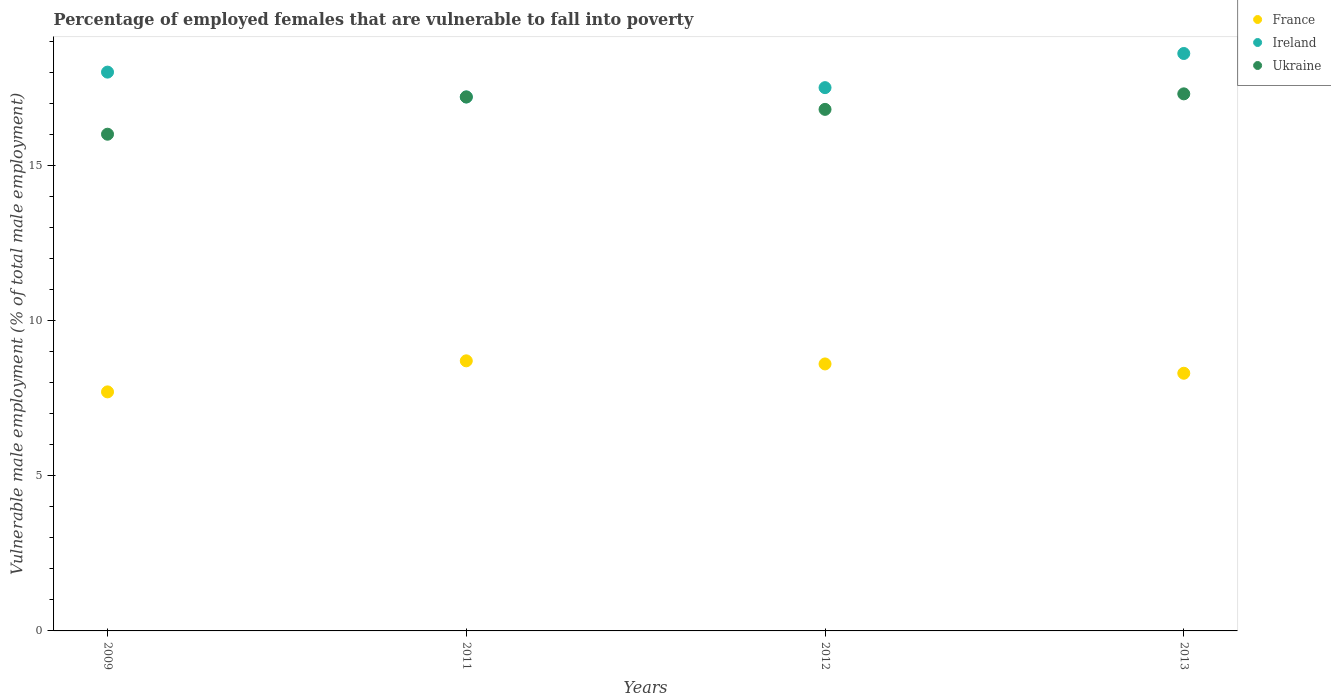How many different coloured dotlines are there?
Your response must be concise. 3. What is the percentage of employed females who are vulnerable to fall into poverty in France in 2011?
Offer a terse response. 8.7. Across all years, what is the maximum percentage of employed females who are vulnerable to fall into poverty in Ireland?
Provide a short and direct response. 18.6. In which year was the percentage of employed females who are vulnerable to fall into poverty in Ireland minimum?
Ensure brevity in your answer.  2011. What is the total percentage of employed females who are vulnerable to fall into poverty in Ireland in the graph?
Your answer should be compact. 71.3. What is the difference between the percentage of employed females who are vulnerable to fall into poverty in Ukraine in 2011 and that in 2013?
Provide a short and direct response. -0.1. What is the difference between the percentage of employed females who are vulnerable to fall into poverty in Ireland in 2011 and the percentage of employed females who are vulnerable to fall into poverty in France in 2009?
Your answer should be compact. 9.5. What is the average percentage of employed females who are vulnerable to fall into poverty in Ukraine per year?
Your response must be concise. 16.82. In the year 2011, what is the difference between the percentage of employed females who are vulnerable to fall into poverty in France and percentage of employed females who are vulnerable to fall into poverty in Ireland?
Your response must be concise. -8.5. In how many years, is the percentage of employed females who are vulnerable to fall into poverty in France greater than 1 %?
Provide a short and direct response. 4. What is the ratio of the percentage of employed females who are vulnerable to fall into poverty in Ukraine in 2012 to that in 2013?
Make the answer very short. 0.97. What is the difference between the highest and the second highest percentage of employed females who are vulnerable to fall into poverty in Ireland?
Offer a terse response. 0.6. What is the difference between the highest and the lowest percentage of employed females who are vulnerable to fall into poverty in France?
Provide a short and direct response. 1. How many years are there in the graph?
Provide a short and direct response. 4. What is the difference between two consecutive major ticks on the Y-axis?
Your answer should be very brief. 5. Does the graph contain grids?
Your response must be concise. No. Where does the legend appear in the graph?
Provide a short and direct response. Top right. How many legend labels are there?
Make the answer very short. 3. What is the title of the graph?
Your answer should be very brief. Percentage of employed females that are vulnerable to fall into poverty. Does "Cameroon" appear as one of the legend labels in the graph?
Provide a succinct answer. No. What is the label or title of the X-axis?
Your response must be concise. Years. What is the label or title of the Y-axis?
Provide a succinct answer. Vulnerable male employment (% of total male employment). What is the Vulnerable male employment (% of total male employment) of France in 2009?
Offer a terse response. 7.7. What is the Vulnerable male employment (% of total male employment) in France in 2011?
Your answer should be very brief. 8.7. What is the Vulnerable male employment (% of total male employment) in Ireland in 2011?
Ensure brevity in your answer.  17.2. What is the Vulnerable male employment (% of total male employment) in Ukraine in 2011?
Make the answer very short. 17.2. What is the Vulnerable male employment (% of total male employment) of France in 2012?
Give a very brief answer. 8.6. What is the Vulnerable male employment (% of total male employment) of Ireland in 2012?
Give a very brief answer. 17.5. What is the Vulnerable male employment (% of total male employment) of Ukraine in 2012?
Ensure brevity in your answer.  16.8. What is the Vulnerable male employment (% of total male employment) in France in 2013?
Provide a short and direct response. 8.3. What is the Vulnerable male employment (% of total male employment) of Ireland in 2013?
Give a very brief answer. 18.6. What is the Vulnerable male employment (% of total male employment) of Ukraine in 2013?
Your answer should be compact. 17.3. Across all years, what is the maximum Vulnerable male employment (% of total male employment) of France?
Offer a very short reply. 8.7. Across all years, what is the maximum Vulnerable male employment (% of total male employment) in Ireland?
Offer a terse response. 18.6. Across all years, what is the maximum Vulnerable male employment (% of total male employment) in Ukraine?
Provide a short and direct response. 17.3. Across all years, what is the minimum Vulnerable male employment (% of total male employment) of France?
Offer a terse response. 7.7. Across all years, what is the minimum Vulnerable male employment (% of total male employment) in Ireland?
Keep it short and to the point. 17.2. Across all years, what is the minimum Vulnerable male employment (% of total male employment) of Ukraine?
Your answer should be compact. 16. What is the total Vulnerable male employment (% of total male employment) of France in the graph?
Your answer should be compact. 33.3. What is the total Vulnerable male employment (% of total male employment) in Ireland in the graph?
Provide a short and direct response. 71.3. What is the total Vulnerable male employment (% of total male employment) of Ukraine in the graph?
Offer a very short reply. 67.3. What is the difference between the Vulnerable male employment (% of total male employment) in France in 2009 and that in 2011?
Offer a terse response. -1. What is the difference between the Vulnerable male employment (% of total male employment) in Ukraine in 2009 and that in 2011?
Give a very brief answer. -1.2. What is the difference between the Vulnerable male employment (% of total male employment) in France in 2009 and that in 2012?
Provide a short and direct response. -0.9. What is the difference between the Vulnerable male employment (% of total male employment) in Ireland in 2009 and that in 2012?
Offer a very short reply. 0.5. What is the difference between the Vulnerable male employment (% of total male employment) of Ukraine in 2009 and that in 2012?
Your answer should be very brief. -0.8. What is the difference between the Vulnerable male employment (% of total male employment) of Ireland in 2009 and that in 2013?
Ensure brevity in your answer.  -0.6. What is the difference between the Vulnerable male employment (% of total male employment) in Ukraine in 2009 and that in 2013?
Your answer should be very brief. -1.3. What is the difference between the Vulnerable male employment (% of total male employment) in France in 2011 and that in 2012?
Offer a very short reply. 0.1. What is the difference between the Vulnerable male employment (% of total male employment) in Ireland in 2011 and that in 2012?
Provide a short and direct response. -0.3. What is the difference between the Vulnerable male employment (% of total male employment) of France in 2011 and that in 2013?
Offer a very short reply. 0.4. What is the difference between the Vulnerable male employment (% of total male employment) in Ireland in 2011 and that in 2013?
Ensure brevity in your answer.  -1.4. What is the difference between the Vulnerable male employment (% of total male employment) of Ukraine in 2011 and that in 2013?
Provide a succinct answer. -0.1. What is the difference between the Vulnerable male employment (% of total male employment) of France in 2009 and the Vulnerable male employment (% of total male employment) of Ukraine in 2011?
Offer a terse response. -9.5. What is the difference between the Vulnerable male employment (% of total male employment) in Ireland in 2009 and the Vulnerable male employment (% of total male employment) in Ukraine in 2011?
Give a very brief answer. 0.8. What is the difference between the Vulnerable male employment (% of total male employment) of France in 2009 and the Vulnerable male employment (% of total male employment) of Ukraine in 2012?
Make the answer very short. -9.1. What is the difference between the Vulnerable male employment (% of total male employment) in France in 2009 and the Vulnerable male employment (% of total male employment) in Ireland in 2013?
Make the answer very short. -10.9. What is the difference between the Vulnerable male employment (% of total male employment) in Ireland in 2009 and the Vulnerable male employment (% of total male employment) in Ukraine in 2013?
Your response must be concise. 0.7. What is the difference between the Vulnerable male employment (% of total male employment) in France in 2011 and the Vulnerable male employment (% of total male employment) in Ireland in 2012?
Offer a very short reply. -8.8. What is the difference between the Vulnerable male employment (% of total male employment) of Ireland in 2011 and the Vulnerable male employment (% of total male employment) of Ukraine in 2012?
Provide a succinct answer. 0.4. What is the difference between the Vulnerable male employment (% of total male employment) of France in 2012 and the Vulnerable male employment (% of total male employment) of Ukraine in 2013?
Your answer should be compact. -8.7. What is the average Vulnerable male employment (% of total male employment) of France per year?
Ensure brevity in your answer.  8.32. What is the average Vulnerable male employment (% of total male employment) of Ireland per year?
Provide a short and direct response. 17.82. What is the average Vulnerable male employment (% of total male employment) of Ukraine per year?
Provide a short and direct response. 16.82. In the year 2011, what is the difference between the Vulnerable male employment (% of total male employment) of Ireland and Vulnerable male employment (% of total male employment) of Ukraine?
Make the answer very short. 0. In the year 2013, what is the difference between the Vulnerable male employment (% of total male employment) of Ireland and Vulnerable male employment (% of total male employment) of Ukraine?
Offer a very short reply. 1.3. What is the ratio of the Vulnerable male employment (% of total male employment) in France in 2009 to that in 2011?
Your response must be concise. 0.89. What is the ratio of the Vulnerable male employment (% of total male employment) in Ireland in 2009 to that in 2011?
Offer a very short reply. 1.05. What is the ratio of the Vulnerable male employment (% of total male employment) in Ukraine in 2009 to that in 2011?
Give a very brief answer. 0.93. What is the ratio of the Vulnerable male employment (% of total male employment) in France in 2009 to that in 2012?
Make the answer very short. 0.9. What is the ratio of the Vulnerable male employment (% of total male employment) of Ireland in 2009 to that in 2012?
Provide a short and direct response. 1.03. What is the ratio of the Vulnerable male employment (% of total male employment) of France in 2009 to that in 2013?
Your response must be concise. 0.93. What is the ratio of the Vulnerable male employment (% of total male employment) in Ukraine in 2009 to that in 2013?
Make the answer very short. 0.92. What is the ratio of the Vulnerable male employment (% of total male employment) in France in 2011 to that in 2012?
Offer a terse response. 1.01. What is the ratio of the Vulnerable male employment (% of total male employment) in Ireland in 2011 to that in 2012?
Give a very brief answer. 0.98. What is the ratio of the Vulnerable male employment (% of total male employment) in Ukraine in 2011 to that in 2012?
Offer a very short reply. 1.02. What is the ratio of the Vulnerable male employment (% of total male employment) of France in 2011 to that in 2013?
Offer a very short reply. 1.05. What is the ratio of the Vulnerable male employment (% of total male employment) in Ireland in 2011 to that in 2013?
Your answer should be very brief. 0.92. What is the ratio of the Vulnerable male employment (% of total male employment) in France in 2012 to that in 2013?
Your answer should be very brief. 1.04. What is the ratio of the Vulnerable male employment (% of total male employment) of Ireland in 2012 to that in 2013?
Provide a short and direct response. 0.94. What is the ratio of the Vulnerable male employment (% of total male employment) in Ukraine in 2012 to that in 2013?
Your answer should be compact. 0.97. What is the difference between the highest and the second highest Vulnerable male employment (% of total male employment) in France?
Make the answer very short. 0.1. What is the difference between the highest and the second highest Vulnerable male employment (% of total male employment) of Ireland?
Make the answer very short. 0.6. What is the difference between the highest and the lowest Vulnerable male employment (% of total male employment) of France?
Provide a short and direct response. 1. 